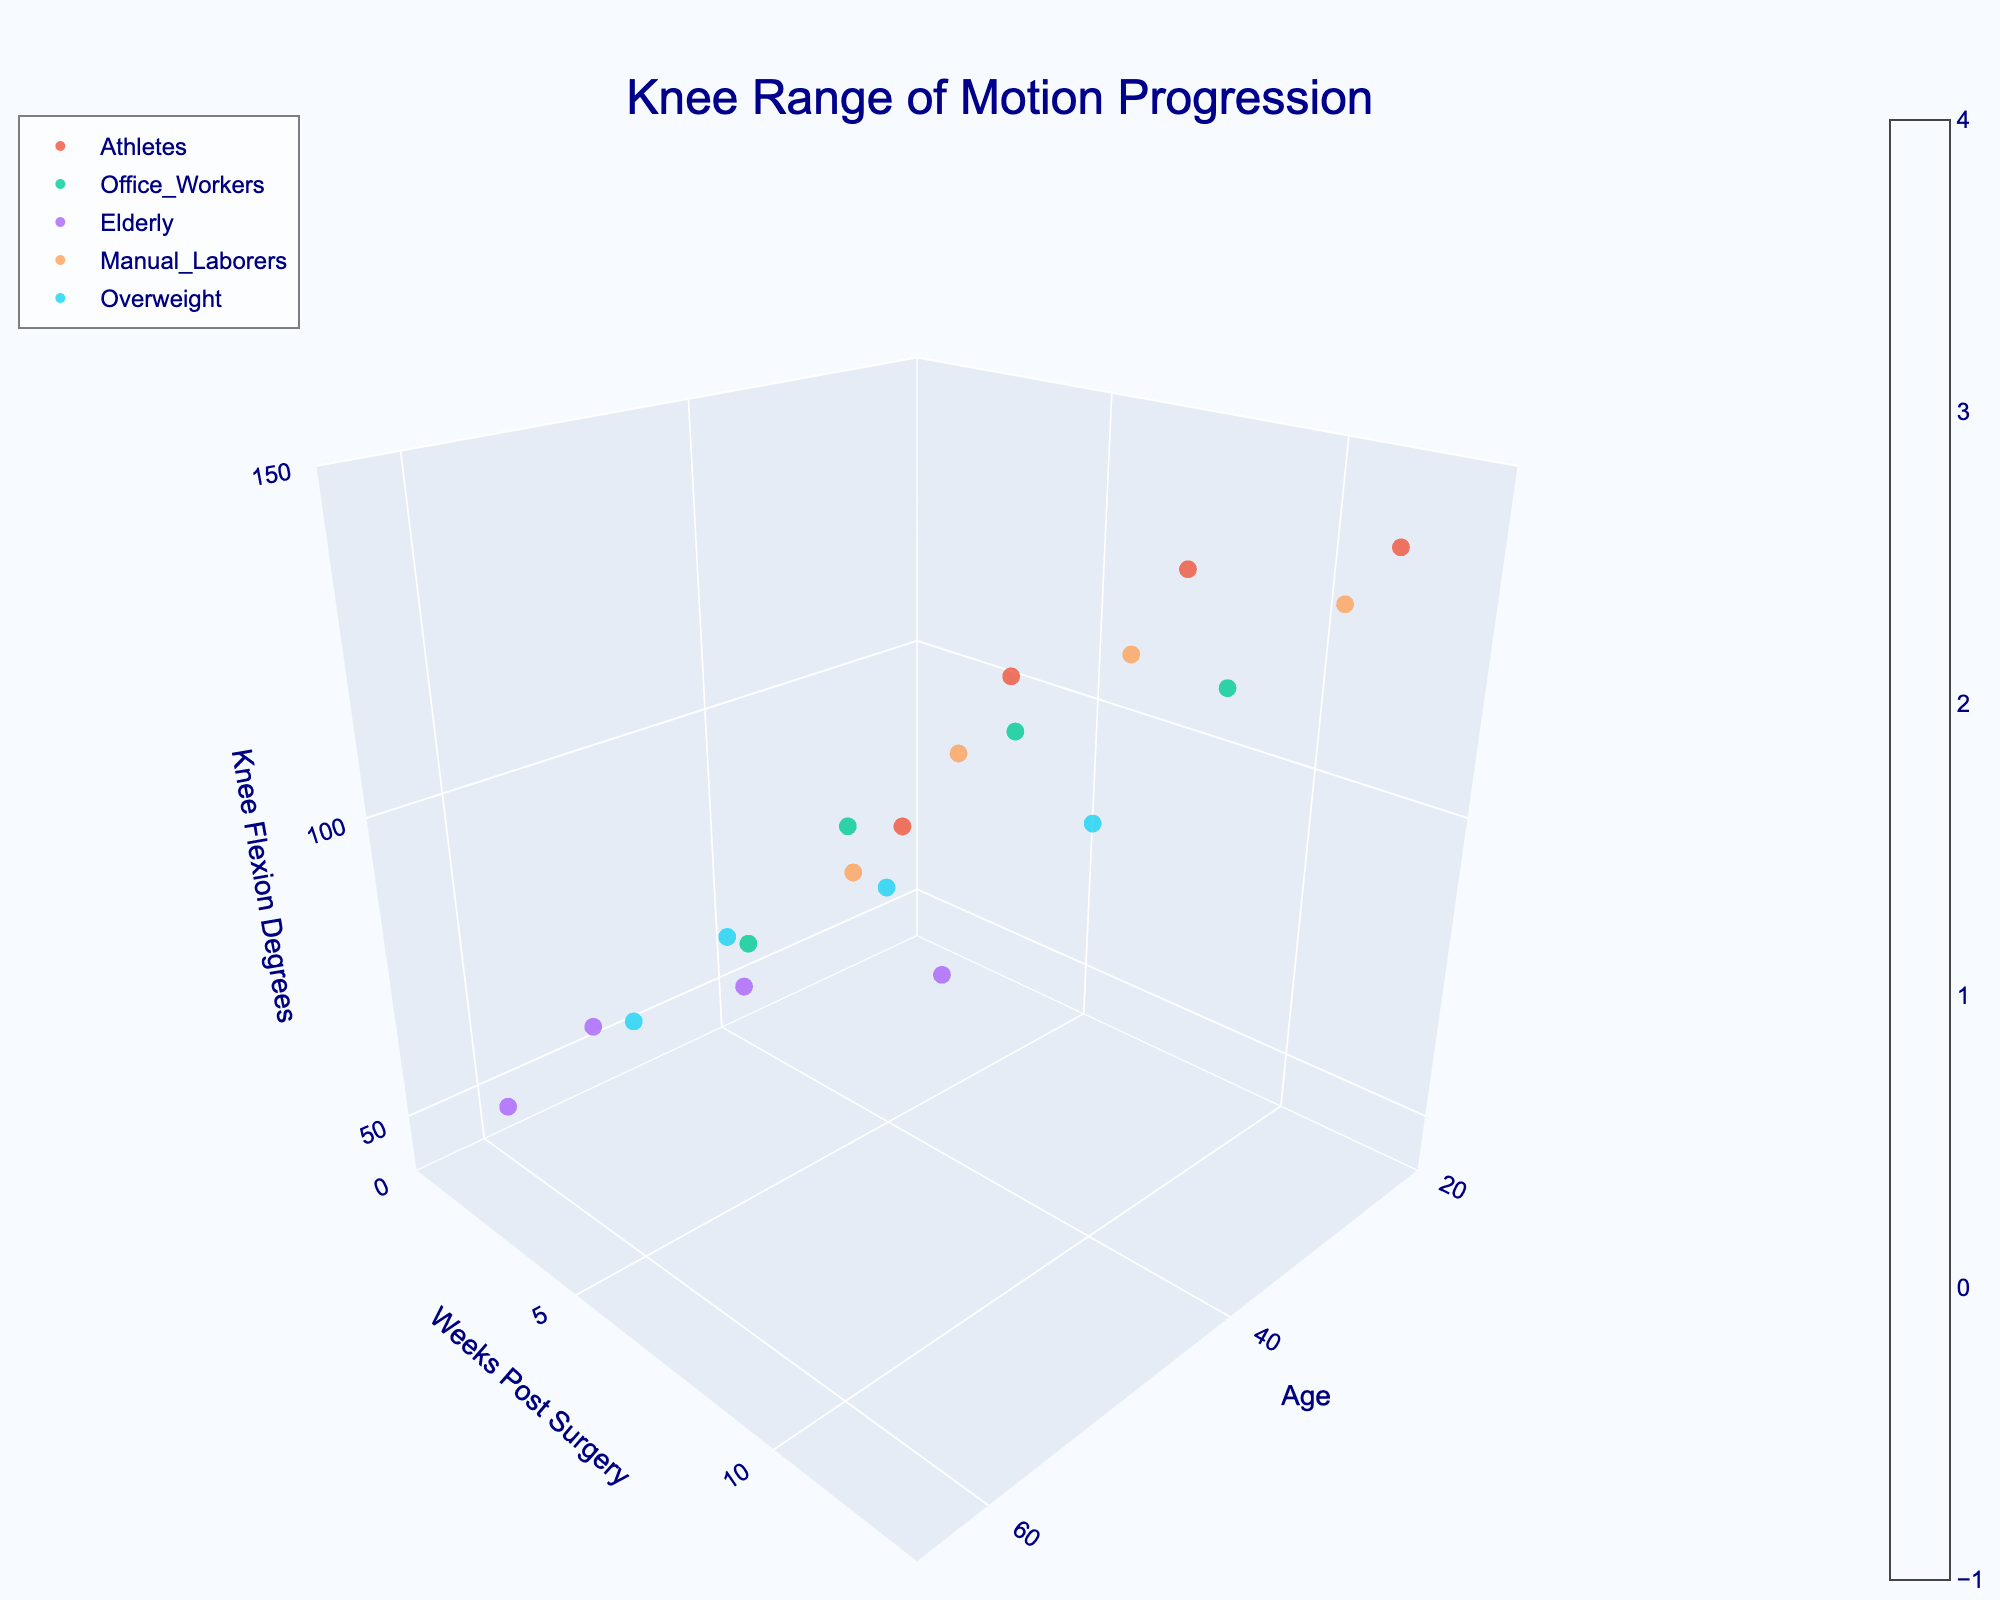What is the title of the figure? The title is usually placed prominently at the top of the figure. In this case, it is explicitly set in the `generate_plot` function.
Answer: Knee Range of Motion Progression What are the three axes labeled in the plot? The axes labels are specified in the `update_layout` function under `scene`. The 'x' axis title is 'Age', the 'y' axis title is 'Weeks Post Surgery', and the 'z' axis title is 'Knee Flexion Degrees'.
Answer: Age, Weeks Post Surgery, Knee Flexion Degrees Which patient group achieved the highest knee flexion degrees by week 12? By looking at the end of the timeline for each group, we can see that the 'Athletes' group reached the highest knee flexion degrees of 140° by week 12.
Answer: Athletes How does knee flexion degrees progression for 'Elderly' patients compare to that of 'Manual Laborers'? Comparing the progression, 'Elderly' patients improve from 50° to 110°, while 'Manual Laborers' improve from 65° to 135°. 'Manual Laborers' show a larger improvement overall by 25° more than 'Elderly' patients.
Answer: Manual Laborers improve more What is the knee flexion increase for 'Office Workers' from week 1 to week 4? For 'Office Workers', the knee flexion degrees increase from 60° at week 1 to 90° at week 4. The difference is calculated as 90 - 60.
Answer: 30 degrees At week 8, which age group has shown the least improvement in knee flexion degrees? By observing the knee flexion degrees at week 8 for each age group, the 'Elderly' group (age 60) shows the least improvement, reaching 95°.
Answer: Elderly How many patient groups are represented in the plot? Each unique patient group is plotted and the number of unique groups is indicated in the plot legend: Athletes, Office Workers, Elderly, Manual Laborers, and Overweight.
Answer: 5 Which patient group has the earliest visible data point at week 1? All patient groups have data points at week 1. This can be confirmed by observing the starting points on the 'y' axis for each group.
Answer: All groups Between which weeks does the 'Overweight' group show the greatest increase in knee flexion degrees? Observing the data points for the 'Overweight' group, the greatest increase occurs between weeks 1 and 4, from 55° to 80°. The difference is 25°.
Answer: Between weeks 1 and 4 What color scheme is used for the volume plot? The color scheme mentioned in the code for the volume plot is 'Viridis', which is a gradient varying from dark blue to yellow-green.
Answer: Viridis 